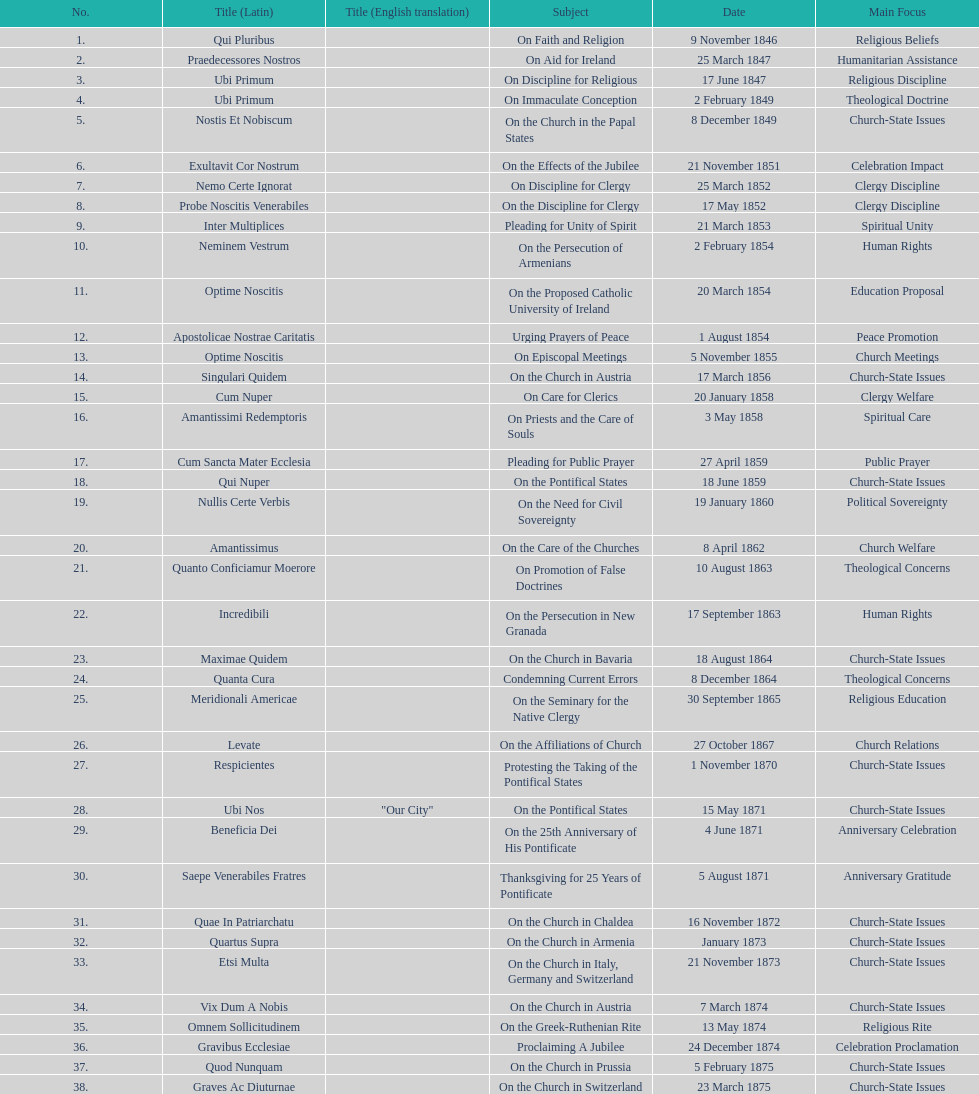Date of the last encyclical whose subject contained the word "pontificate" 5 August 1871. Can you give me this table as a dict? {'header': ['No.', 'Title (Latin)', 'Title (English translation)', 'Subject', 'Date', 'Main Focus'], 'rows': [['1.', 'Qui Pluribus', '', 'On Faith and Religion', '9 November 1846', 'Religious Beliefs'], ['2.', 'Praedecessores Nostros', '', 'On Aid for Ireland', '25 March 1847', 'Humanitarian Assistance'], ['3.', 'Ubi Primum', '', 'On Discipline for Religious', '17 June 1847', 'Religious Discipline'], ['4.', 'Ubi Primum', '', 'On Immaculate Conception', '2 February 1849', 'Theological Doctrine'], ['5.', 'Nostis Et Nobiscum', '', 'On the Church in the Papal States', '8 December 1849', 'Church-State Issues'], ['6.', 'Exultavit Cor Nostrum', '', 'On the Effects of the Jubilee', '21 November 1851', 'Celebration Impact'], ['7.', 'Nemo Certe Ignorat', '', 'On Discipline for Clergy', '25 March 1852', 'Clergy Discipline'], ['8.', 'Probe Noscitis Venerabiles', '', 'On the Discipline for Clergy', '17 May 1852', 'Clergy Discipline'], ['9.', 'Inter Multiplices', '', 'Pleading for Unity of Spirit', '21 March 1853', 'Spiritual Unity'], ['10.', 'Neminem Vestrum', '', 'On the Persecution of Armenians', '2 February 1854', 'Human Rights'], ['11.', 'Optime Noscitis', '', 'On the Proposed Catholic University of Ireland', '20 March 1854', 'Education Proposal'], ['12.', 'Apostolicae Nostrae Caritatis', '', 'Urging Prayers of Peace', '1 August 1854', 'Peace Promotion'], ['13.', 'Optime Noscitis', '', 'On Episcopal Meetings', '5 November 1855', 'Church Meetings'], ['14.', 'Singulari Quidem', '', 'On the Church in Austria', '17 March 1856', 'Church-State Issues'], ['15.', 'Cum Nuper', '', 'On Care for Clerics', '20 January 1858', 'Clergy Welfare'], ['16.', 'Amantissimi Redemptoris', '', 'On Priests and the Care of Souls', '3 May 1858', 'Spiritual Care'], ['17.', 'Cum Sancta Mater Ecclesia', '', 'Pleading for Public Prayer', '27 April 1859', 'Public Prayer'], ['18.', 'Qui Nuper', '', 'On the Pontifical States', '18 June 1859', 'Church-State Issues'], ['19.', 'Nullis Certe Verbis', '', 'On the Need for Civil Sovereignty', '19 January 1860', 'Political Sovereignty'], ['20.', 'Amantissimus', '', 'On the Care of the Churches', '8 April 1862', 'Church Welfare'], ['21.', 'Quanto Conficiamur Moerore', '', 'On Promotion of False Doctrines', '10 August 1863', 'Theological Concerns'], ['22.', 'Incredibili', '', 'On the Persecution in New Granada', '17 September 1863', 'Human Rights'], ['23.', 'Maximae Quidem', '', 'On the Church in Bavaria', '18 August 1864', 'Church-State Issues'], ['24.', 'Quanta Cura', '', 'Condemning Current Errors', '8 December 1864', 'Theological Concerns'], ['25.', 'Meridionali Americae', '', 'On the Seminary for the Native Clergy', '30 September 1865', 'Religious Education'], ['26.', 'Levate', '', 'On the Affiliations of Church', '27 October 1867', 'Church Relations'], ['27.', 'Respicientes', '', 'Protesting the Taking of the Pontifical States', '1 November 1870', 'Church-State Issues'], ['28.', 'Ubi Nos', '"Our City"', 'On the Pontifical States', '15 May 1871', 'Church-State Issues'], ['29.', 'Beneficia Dei', '', 'On the 25th Anniversary of His Pontificate', '4 June 1871', 'Anniversary Celebration'], ['30.', 'Saepe Venerabiles Fratres', '', 'Thanksgiving for 25 Years of Pontificate', '5 August 1871', 'Anniversary Gratitude'], ['31.', 'Quae In Patriarchatu', '', 'On the Church in Chaldea', '16 November 1872', 'Church-State Issues'], ['32.', 'Quartus Supra', '', 'On the Church in Armenia', 'January 1873', 'Church-State Issues'], ['33.', 'Etsi Multa', '', 'On the Church in Italy, Germany and Switzerland', '21 November 1873', 'Church-State Issues'], ['34.', 'Vix Dum A Nobis', '', 'On the Church in Austria', '7 March 1874', 'Church-State Issues'], ['35.', 'Omnem Sollicitudinem', '', 'On the Greek-Ruthenian Rite', '13 May 1874', 'Religious Rite'], ['36.', 'Gravibus Ecclesiae', '', 'Proclaiming A Jubilee', '24 December 1874', 'Celebration Proclamation'], ['37.', 'Quod Nunquam', '', 'On the Church in Prussia', '5 February 1875', 'Church-State Issues'], ['38.', 'Graves Ac Diuturnae', '', 'On the Church in Switzerland', '23 March 1875', 'Church-State Issues']]} 